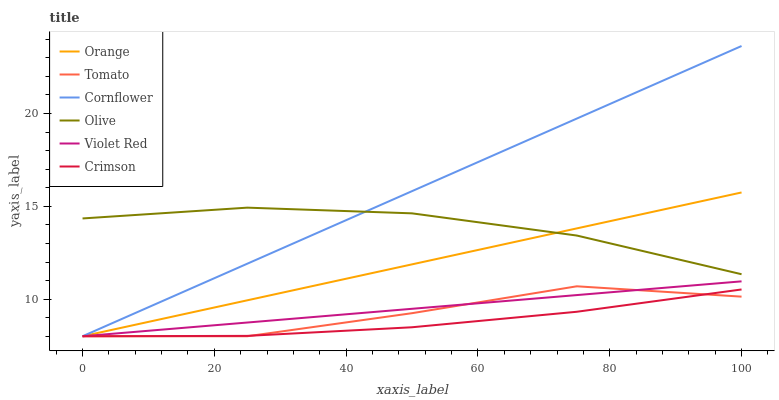Does Crimson have the minimum area under the curve?
Answer yes or no. Yes. Does Cornflower have the maximum area under the curve?
Answer yes or no. Yes. Does Violet Red have the minimum area under the curve?
Answer yes or no. No. Does Violet Red have the maximum area under the curve?
Answer yes or no. No. Is Cornflower the smoothest?
Answer yes or no. Yes. Is Tomato the roughest?
Answer yes or no. Yes. Is Violet Red the smoothest?
Answer yes or no. No. Is Violet Red the roughest?
Answer yes or no. No. Does Tomato have the lowest value?
Answer yes or no. Yes. Does Olive have the lowest value?
Answer yes or no. No. Does Cornflower have the highest value?
Answer yes or no. Yes. Does Violet Red have the highest value?
Answer yes or no. No. Is Crimson less than Olive?
Answer yes or no. Yes. Is Olive greater than Crimson?
Answer yes or no. Yes. Does Orange intersect Tomato?
Answer yes or no. Yes. Is Orange less than Tomato?
Answer yes or no. No. Is Orange greater than Tomato?
Answer yes or no. No. Does Crimson intersect Olive?
Answer yes or no. No. 